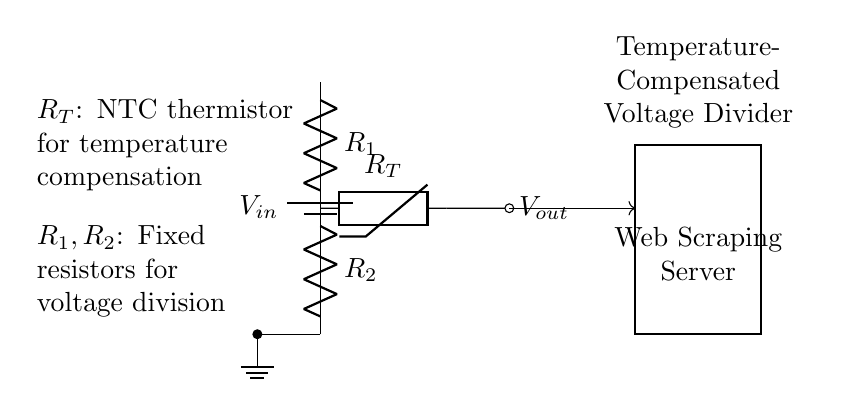What is the purpose of the thermistor in this circuit? The thermistor is used for temperature compensation, which helps stabilize the output voltage against temperature variations. Its resistance changes with temperature, allowing the circuit to adjust the voltage accordingly.
Answer: Temperature compensation What are the components used in the voltage divider? The voltage divider consists of two fixed resistors (R1 and R2) and a thermistor (RT) as a temperature compensation element. The resistors are connected in series to provide a voltage output that is a fraction of the input voltage.
Answer: R1, R2, RT What is the output voltage reference in this circuit? The output voltage (Vout) is measured across the thermistor (RT), which is connected in series with the fixed resistors (R1 and R2). It represents the reduced voltage intended for the web scraping server.
Answer: Vout Why use a voltage divider for power supply stabilization? A voltage divider allows for a simple way to obtain a lower voltage from a higher voltage source. It divides the input voltage into a desired output voltage that can power devices like web scraping servers, while also including compensation for temperature variations.
Answer: Simplicity and voltage adjustment How are the resistors arranged in the voltage divider? The resistors R1 and R2 are arranged in series across the input voltage (Vin), where R1 is at the top and R2 is at the bottom, creating a voltage drop that results in the divided output voltage.
Answer: In series 